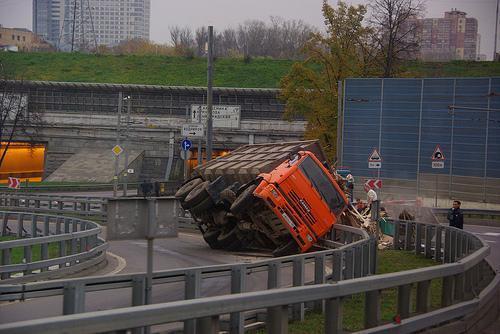How many trucks are in the photo?
Give a very brief answer. 1. 